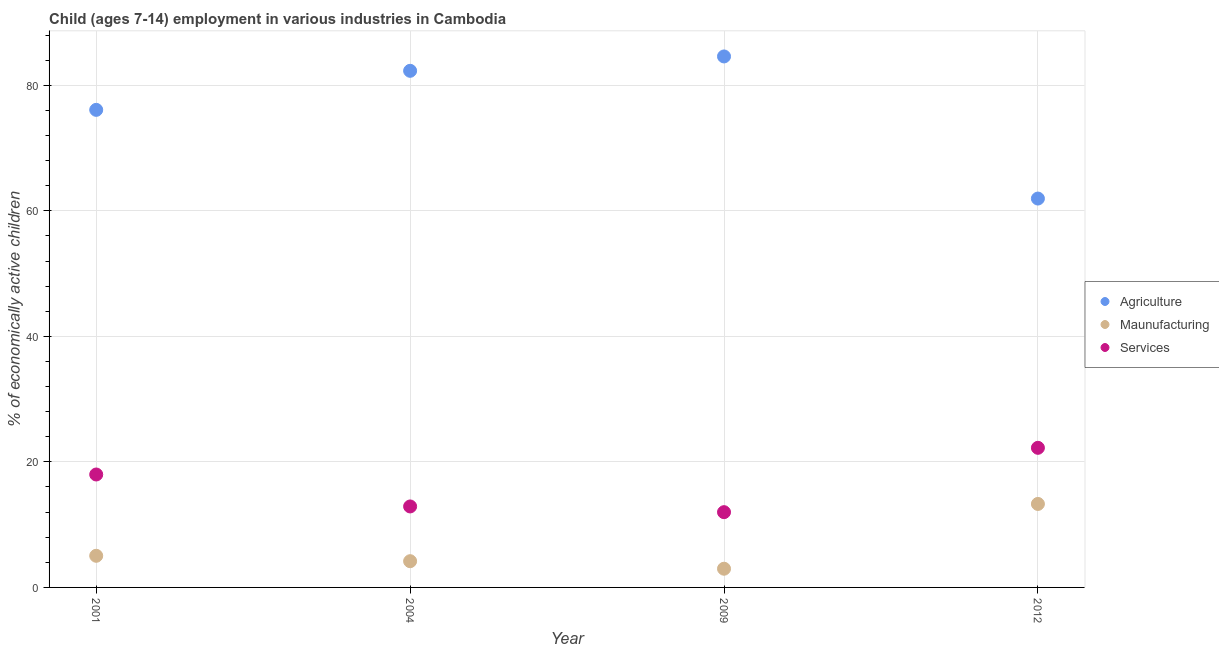Is the number of dotlines equal to the number of legend labels?
Give a very brief answer. Yes. What is the percentage of economically active children in manufacturing in 2004?
Give a very brief answer. 4.18. Across all years, what is the maximum percentage of economically active children in services?
Make the answer very short. 22.24. Across all years, what is the minimum percentage of economically active children in agriculture?
Offer a terse response. 61.95. What is the total percentage of economically active children in services in the graph?
Ensure brevity in your answer.  65.12. What is the difference between the percentage of economically active children in agriculture in 2001 and that in 2004?
Provide a short and direct response. -6.22. What is the difference between the percentage of economically active children in agriculture in 2001 and the percentage of economically active children in services in 2004?
Ensure brevity in your answer.  63.18. What is the average percentage of economically active children in manufacturing per year?
Keep it short and to the point. 6.38. In the year 2012, what is the difference between the percentage of economically active children in manufacturing and percentage of economically active children in agriculture?
Offer a very short reply. -48.65. In how many years, is the percentage of economically active children in services greater than 12 %?
Your answer should be compact. 3. What is the ratio of the percentage of economically active children in agriculture in 2001 to that in 2012?
Make the answer very short. 1.23. Is the percentage of economically active children in services in 2001 less than that in 2012?
Your answer should be compact. Yes. What is the difference between the highest and the second highest percentage of economically active children in services?
Offer a terse response. 4.25. What is the difference between the highest and the lowest percentage of economically active children in agriculture?
Give a very brief answer. 22.64. Is it the case that in every year, the sum of the percentage of economically active children in agriculture and percentage of economically active children in manufacturing is greater than the percentage of economically active children in services?
Offer a very short reply. Yes. Is the percentage of economically active children in manufacturing strictly less than the percentage of economically active children in agriculture over the years?
Your answer should be compact. Yes. How many dotlines are there?
Make the answer very short. 3. How many years are there in the graph?
Ensure brevity in your answer.  4. What is the difference between two consecutive major ticks on the Y-axis?
Ensure brevity in your answer.  20. Does the graph contain any zero values?
Your answer should be very brief. No. Does the graph contain grids?
Offer a very short reply. Yes. How are the legend labels stacked?
Give a very brief answer. Vertical. What is the title of the graph?
Your answer should be very brief. Child (ages 7-14) employment in various industries in Cambodia. What is the label or title of the X-axis?
Your answer should be very brief. Year. What is the label or title of the Y-axis?
Offer a very short reply. % of economically active children. What is the % of economically active children in Agriculture in 2001?
Make the answer very short. 76.08. What is the % of economically active children in Maunufacturing in 2001?
Ensure brevity in your answer.  5.04. What is the % of economically active children in Services in 2001?
Your answer should be compact. 17.99. What is the % of economically active children in Agriculture in 2004?
Your response must be concise. 82.3. What is the % of economically active children in Maunufacturing in 2004?
Keep it short and to the point. 4.18. What is the % of economically active children of Services in 2004?
Offer a terse response. 12.9. What is the % of economically active children of Agriculture in 2009?
Your answer should be compact. 84.59. What is the % of economically active children of Maunufacturing in 2009?
Your answer should be compact. 2.98. What is the % of economically active children in Services in 2009?
Your response must be concise. 11.99. What is the % of economically active children in Agriculture in 2012?
Keep it short and to the point. 61.95. What is the % of economically active children of Services in 2012?
Ensure brevity in your answer.  22.24. Across all years, what is the maximum % of economically active children in Agriculture?
Your answer should be compact. 84.59. Across all years, what is the maximum % of economically active children of Services?
Ensure brevity in your answer.  22.24. Across all years, what is the minimum % of economically active children of Agriculture?
Ensure brevity in your answer.  61.95. Across all years, what is the minimum % of economically active children of Maunufacturing?
Make the answer very short. 2.98. Across all years, what is the minimum % of economically active children of Services?
Provide a succinct answer. 11.99. What is the total % of economically active children in Agriculture in the graph?
Make the answer very short. 304.92. What is the total % of economically active children of Maunufacturing in the graph?
Keep it short and to the point. 25.5. What is the total % of economically active children of Services in the graph?
Keep it short and to the point. 65.12. What is the difference between the % of economically active children in Agriculture in 2001 and that in 2004?
Keep it short and to the point. -6.22. What is the difference between the % of economically active children in Maunufacturing in 2001 and that in 2004?
Offer a very short reply. 0.86. What is the difference between the % of economically active children in Services in 2001 and that in 2004?
Provide a succinct answer. 5.09. What is the difference between the % of economically active children of Agriculture in 2001 and that in 2009?
Give a very brief answer. -8.51. What is the difference between the % of economically active children in Maunufacturing in 2001 and that in 2009?
Offer a terse response. 2.06. What is the difference between the % of economically active children of Agriculture in 2001 and that in 2012?
Keep it short and to the point. 14.13. What is the difference between the % of economically active children in Maunufacturing in 2001 and that in 2012?
Your answer should be compact. -8.26. What is the difference between the % of economically active children of Services in 2001 and that in 2012?
Provide a succinct answer. -4.25. What is the difference between the % of economically active children in Agriculture in 2004 and that in 2009?
Your answer should be compact. -2.29. What is the difference between the % of economically active children in Services in 2004 and that in 2009?
Make the answer very short. 0.91. What is the difference between the % of economically active children in Agriculture in 2004 and that in 2012?
Provide a succinct answer. 20.35. What is the difference between the % of economically active children of Maunufacturing in 2004 and that in 2012?
Your answer should be compact. -9.12. What is the difference between the % of economically active children of Services in 2004 and that in 2012?
Your answer should be compact. -9.34. What is the difference between the % of economically active children in Agriculture in 2009 and that in 2012?
Your answer should be very brief. 22.64. What is the difference between the % of economically active children of Maunufacturing in 2009 and that in 2012?
Keep it short and to the point. -10.32. What is the difference between the % of economically active children in Services in 2009 and that in 2012?
Your answer should be compact. -10.25. What is the difference between the % of economically active children in Agriculture in 2001 and the % of economically active children in Maunufacturing in 2004?
Ensure brevity in your answer.  71.9. What is the difference between the % of economically active children in Agriculture in 2001 and the % of economically active children in Services in 2004?
Provide a succinct answer. 63.18. What is the difference between the % of economically active children of Maunufacturing in 2001 and the % of economically active children of Services in 2004?
Offer a terse response. -7.86. What is the difference between the % of economically active children in Agriculture in 2001 and the % of economically active children in Maunufacturing in 2009?
Give a very brief answer. 73.1. What is the difference between the % of economically active children in Agriculture in 2001 and the % of economically active children in Services in 2009?
Your answer should be very brief. 64.09. What is the difference between the % of economically active children in Maunufacturing in 2001 and the % of economically active children in Services in 2009?
Your answer should be compact. -6.95. What is the difference between the % of economically active children of Agriculture in 2001 and the % of economically active children of Maunufacturing in 2012?
Give a very brief answer. 62.78. What is the difference between the % of economically active children of Agriculture in 2001 and the % of economically active children of Services in 2012?
Give a very brief answer. 53.84. What is the difference between the % of economically active children in Maunufacturing in 2001 and the % of economically active children in Services in 2012?
Your answer should be compact. -17.2. What is the difference between the % of economically active children of Agriculture in 2004 and the % of economically active children of Maunufacturing in 2009?
Give a very brief answer. 79.32. What is the difference between the % of economically active children of Agriculture in 2004 and the % of economically active children of Services in 2009?
Make the answer very short. 70.31. What is the difference between the % of economically active children of Maunufacturing in 2004 and the % of economically active children of Services in 2009?
Offer a very short reply. -7.81. What is the difference between the % of economically active children of Agriculture in 2004 and the % of economically active children of Maunufacturing in 2012?
Provide a succinct answer. 69. What is the difference between the % of economically active children of Agriculture in 2004 and the % of economically active children of Services in 2012?
Offer a very short reply. 60.06. What is the difference between the % of economically active children of Maunufacturing in 2004 and the % of economically active children of Services in 2012?
Make the answer very short. -18.06. What is the difference between the % of economically active children in Agriculture in 2009 and the % of economically active children in Maunufacturing in 2012?
Keep it short and to the point. 71.29. What is the difference between the % of economically active children in Agriculture in 2009 and the % of economically active children in Services in 2012?
Provide a succinct answer. 62.35. What is the difference between the % of economically active children of Maunufacturing in 2009 and the % of economically active children of Services in 2012?
Offer a very short reply. -19.26. What is the average % of economically active children in Agriculture per year?
Ensure brevity in your answer.  76.23. What is the average % of economically active children of Maunufacturing per year?
Your answer should be compact. 6.38. What is the average % of economically active children in Services per year?
Offer a terse response. 16.28. In the year 2001, what is the difference between the % of economically active children in Agriculture and % of economically active children in Maunufacturing?
Provide a short and direct response. 71.04. In the year 2001, what is the difference between the % of economically active children of Agriculture and % of economically active children of Services?
Your response must be concise. 58.09. In the year 2001, what is the difference between the % of economically active children of Maunufacturing and % of economically active children of Services?
Make the answer very short. -12.95. In the year 2004, what is the difference between the % of economically active children in Agriculture and % of economically active children in Maunufacturing?
Your answer should be compact. 78.12. In the year 2004, what is the difference between the % of economically active children in Agriculture and % of economically active children in Services?
Provide a succinct answer. 69.4. In the year 2004, what is the difference between the % of economically active children in Maunufacturing and % of economically active children in Services?
Ensure brevity in your answer.  -8.72. In the year 2009, what is the difference between the % of economically active children in Agriculture and % of economically active children in Maunufacturing?
Keep it short and to the point. 81.61. In the year 2009, what is the difference between the % of economically active children in Agriculture and % of economically active children in Services?
Provide a short and direct response. 72.6. In the year 2009, what is the difference between the % of economically active children in Maunufacturing and % of economically active children in Services?
Your response must be concise. -9.01. In the year 2012, what is the difference between the % of economically active children in Agriculture and % of economically active children in Maunufacturing?
Offer a terse response. 48.65. In the year 2012, what is the difference between the % of economically active children of Agriculture and % of economically active children of Services?
Ensure brevity in your answer.  39.71. In the year 2012, what is the difference between the % of economically active children of Maunufacturing and % of economically active children of Services?
Provide a succinct answer. -8.94. What is the ratio of the % of economically active children in Agriculture in 2001 to that in 2004?
Your answer should be very brief. 0.92. What is the ratio of the % of economically active children in Maunufacturing in 2001 to that in 2004?
Ensure brevity in your answer.  1.21. What is the ratio of the % of economically active children in Services in 2001 to that in 2004?
Give a very brief answer. 1.39. What is the ratio of the % of economically active children of Agriculture in 2001 to that in 2009?
Provide a succinct answer. 0.9. What is the ratio of the % of economically active children of Maunufacturing in 2001 to that in 2009?
Ensure brevity in your answer.  1.69. What is the ratio of the % of economically active children of Services in 2001 to that in 2009?
Offer a very short reply. 1.5. What is the ratio of the % of economically active children of Agriculture in 2001 to that in 2012?
Keep it short and to the point. 1.23. What is the ratio of the % of economically active children of Maunufacturing in 2001 to that in 2012?
Your response must be concise. 0.38. What is the ratio of the % of economically active children in Services in 2001 to that in 2012?
Offer a very short reply. 0.81. What is the ratio of the % of economically active children in Agriculture in 2004 to that in 2009?
Provide a short and direct response. 0.97. What is the ratio of the % of economically active children in Maunufacturing in 2004 to that in 2009?
Provide a short and direct response. 1.4. What is the ratio of the % of economically active children of Services in 2004 to that in 2009?
Your answer should be compact. 1.08. What is the ratio of the % of economically active children in Agriculture in 2004 to that in 2012?
Provide a succinct answer. 1.33. What is the ratio of the % of economically active children in Maunufacturing in 2004 to that in 2012?
Provide a succinct answer. 0.31. What is the ratio of the % of economically active children in Services in 2004 to that in 2012?
Your response must be concise. 0.58. What is the ratio of the % of economically active children in Agriculture in 2009 to that in 2012?
Ensure brevity in your answer.  1.37. What is the ratio of the % of economically active children in Maunufacturing in 2009 to that in 2012?
Keep it short and to the point. 0.22. What is the ratio of the % of economically active children of Services in 2009 to that in 2012?
Keep it short and to the point. 0.54. What is the difference between the highest and the second highest % of economically active children in Agriculture?
Give a very brief answer. 2.29. What is the difference between the highest and the second highest % of economically active children of Maunufacturing?
Make the answer very short. 8.26. What is the difference between the highest and the second highest % of economically active children in Services?
Ensure brevity in your answer.  4.25. What is the difference between the highest and the lowest % of economically active children of Agriculture?
Your response must be concise. 22.64. What is the difference between the highest and the lowest % of economically active children in Maunufacturing?
Your answer should be compact. 10.32. What is the difference between the highest and the lowest % of economically active children of Services?
Your answer should be compact. 10.25. 